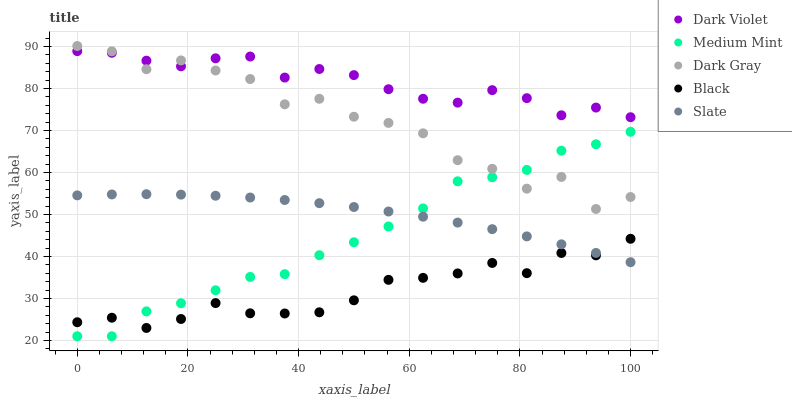Does Black have the minimum area under the curve?
Answer yes or no. Yes. Does Dark Violet have the maximum area under the curve?
Answer yes or no. Yes. Does Dark Gray have the minimum area under the curve?
Answer yes or no. No. Does Dark Gray have the maximum area under the curve?
Answer yes or no. No. Is Slate the smoothest?
Answer yes or no. Yes. Is Dark Gray the roughest?
Answer yes or no. Yes. Is Dark Gray the smoothest?
Answer yes or no. No. Is Slate the roughest?
Answer yes or no. No. Does Medium Mint have the lowest value?
Answer yes or no. Yes. Does Dark Gray have the lowest value?
Answer yes or no. No. Does Dark Gray have the highest value?
Answer yes or no. Yes. Does Slate have the highest value?
Answer yes or no. No. Is Black less than Dark Gray?
Answer yes or no. Yes. Is Dark Violet greater than Black?
Answer yes or no. Yes. Does Black intersect Medium Mint?
Answer yes or no. Yes. Is Black less than Medium Mint?
Answer yes or no. No. Is Black greater than Medium Mint?
Answer yes or no. No. Does Black intersect Dark Gray?
Answer yes or no. No. 